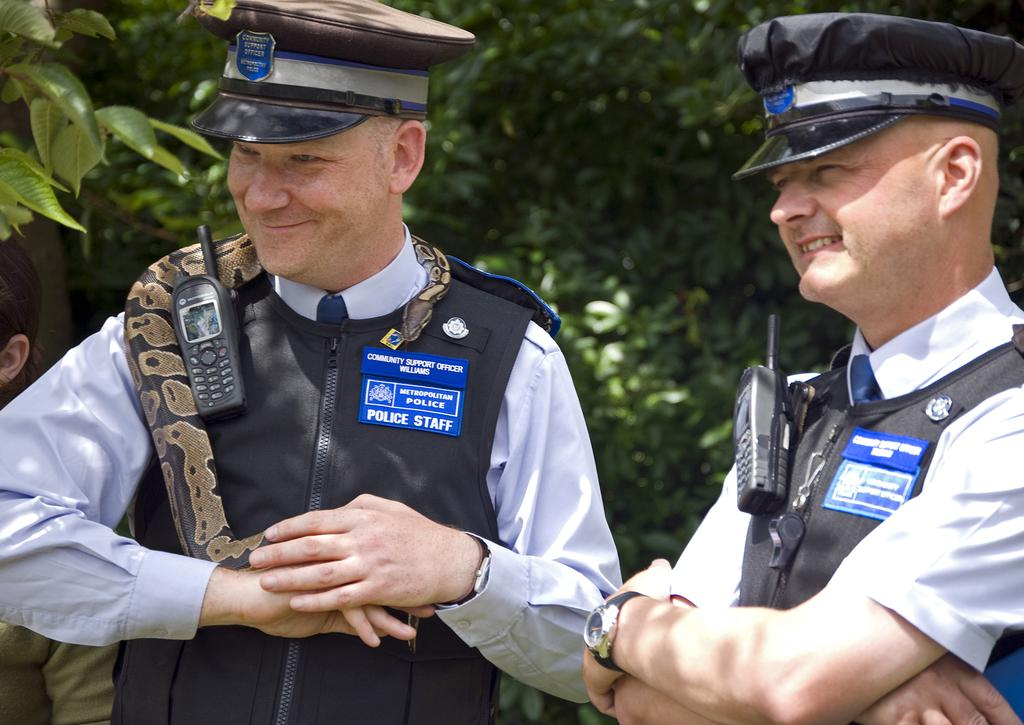<image>
Describe the image concisely. Officers wearing a badge that says "Police Staff". 